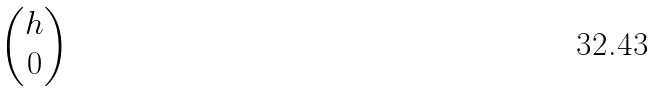<formula> <loc_0><loc_0><loc_500><loc_500>\begin{pmatrix} h \\ 0 \end{pmatrix}</formula> 